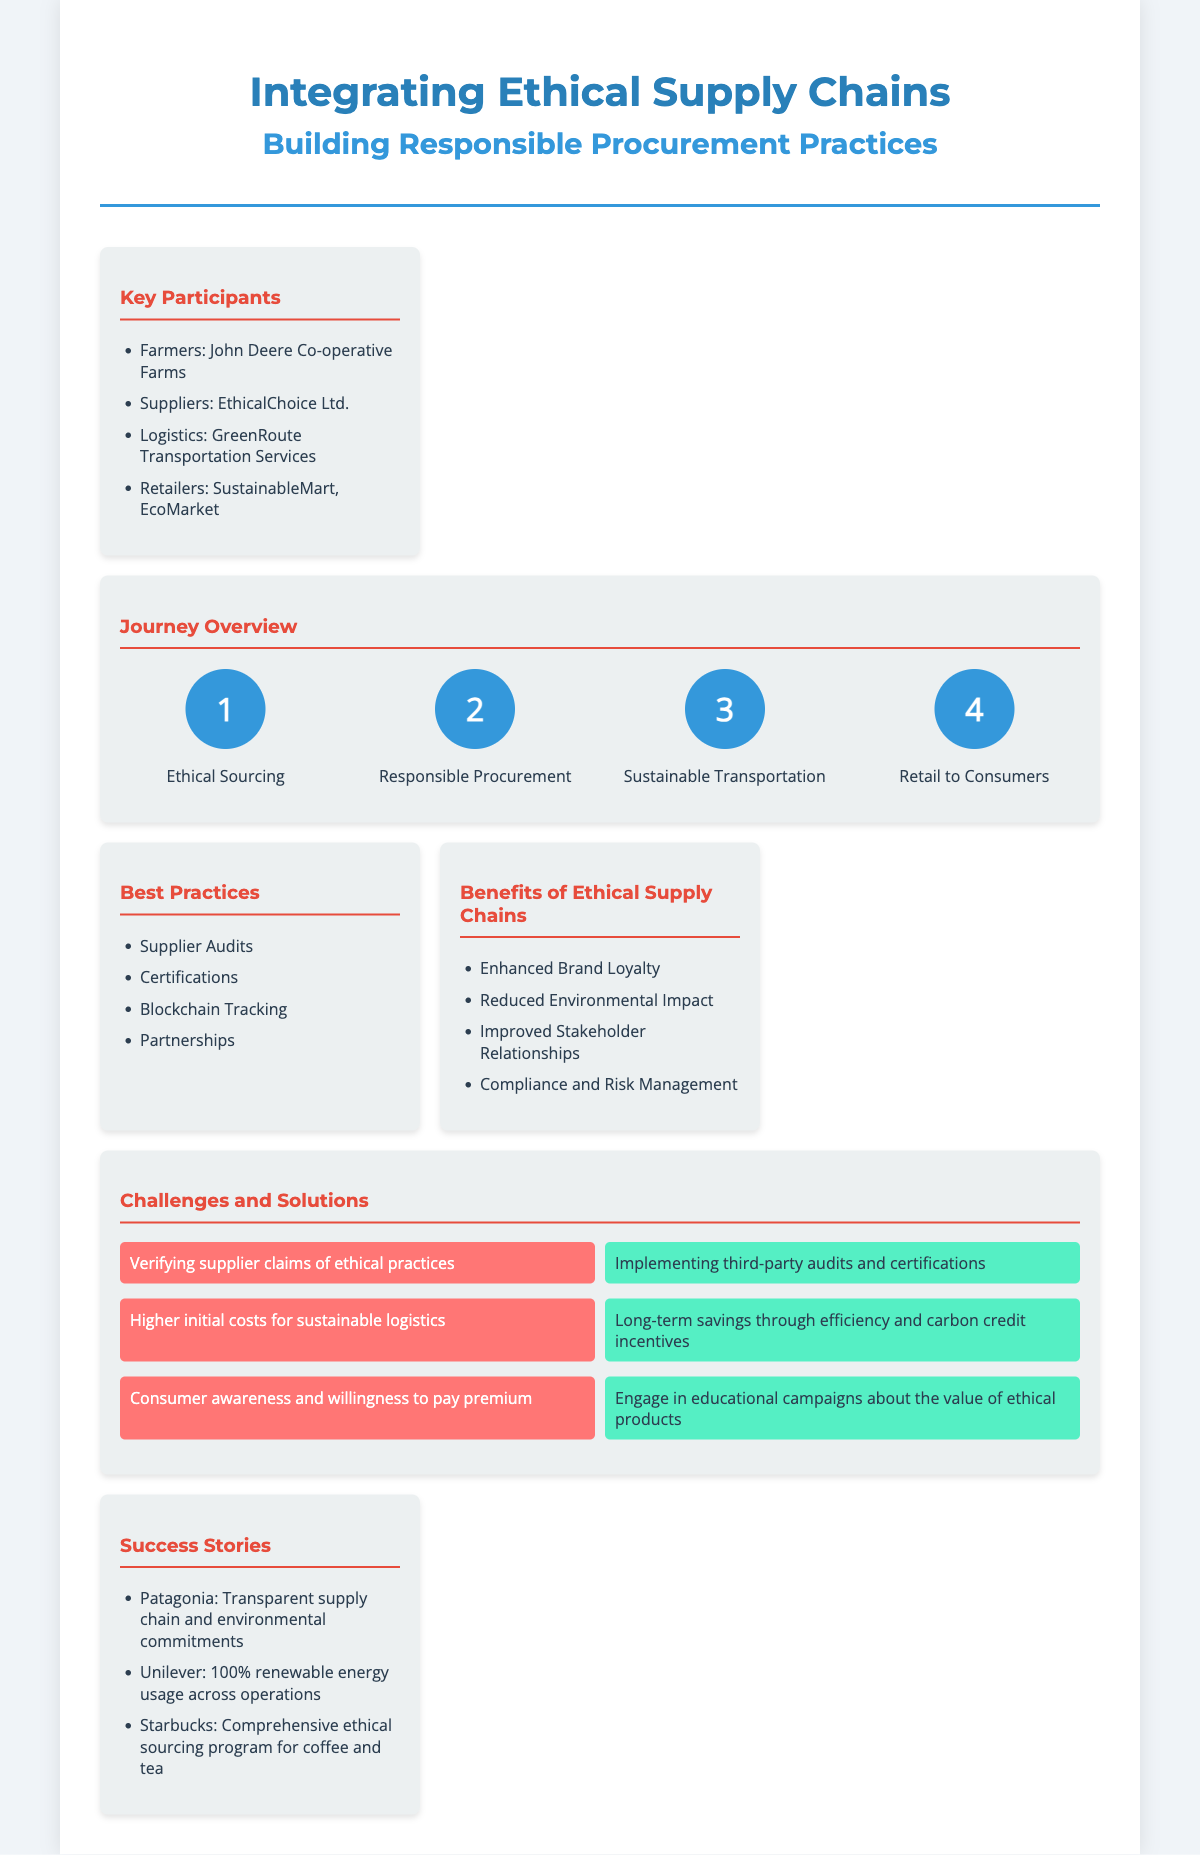What are the key participants in the supply chain? The key participants are listed in the document under "Key Participants," specifically mentioning farmers, suppliers, logistics, and retailers.
Answer: Farmers, Suppliers, Logistics, Retailers What is the first step in the journey overview? The first step is highlighted in the journey overview section of the document, which outlines the steps in order.
Answer: Ethical Sourcing Which company is cited as a farmer participant? The farmer participant is specified in the list of key participants, focusing on the specific farming co-operative mentioned.
Answer: John Deere Co-operative Farms What is one challenge faced in ethical sourcing? The challenges are laid out in the challenges and solutions section, specifically referring to the verification of supplier claims.
Answer: Verifying supplier claims of ethical practices What benefit is associated with ethical supply chains? The benefits are detailed in their own section in the document, showcasing positive outcomes from implementing ethical practices.
Answer: Enhanced Brand Loyalty What solution is proposed for higher initial costs of sustainable logistics? The solutions are provided in the challenges and solutions section, addressing the issue of cost with strategic approaches.
Answer: Long-term savings through efficiency and carbon credit incentives What type of tracking is mentioned as a best practice? The best practices listed refer to methods that can enhance the ethical supply chain's transparency and reliability.
Answer: Blockchain Tracking How many steps are in the journey from farm to market? The journey overview lists the steps involved, and counting these provides the total number of steps in the flow.
Answer: Four 